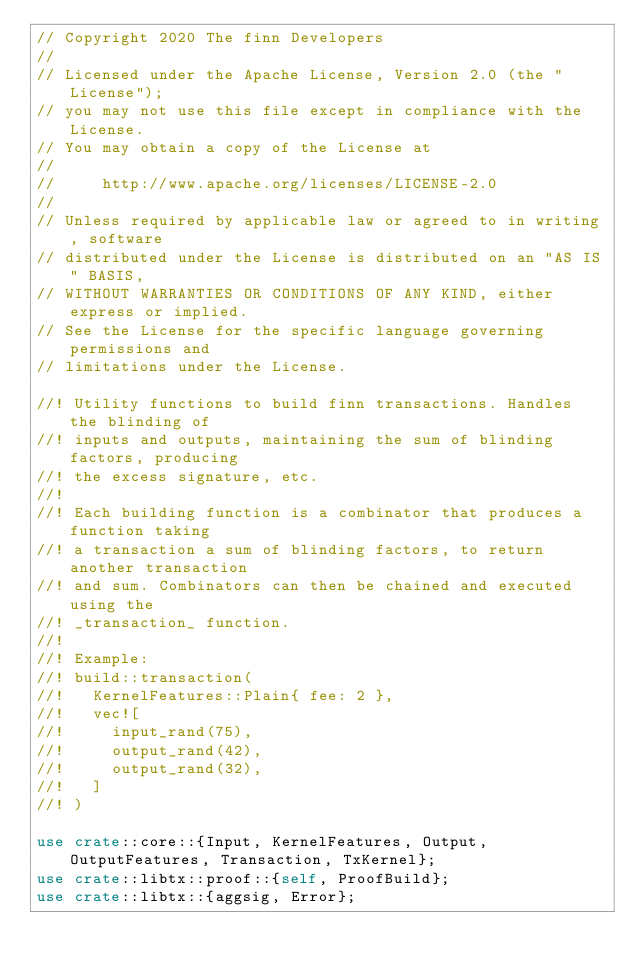<code> <loc_0><loc_0><loc_500><loc_500><_Rust_>// Copyright 2020 The finn Developers
//
// Licensed under the Apache License, Version 2.0 (the "License");
// you may not use this file except in compliance with the License.
// You may obtain a copy of the License at
//
//     http://www.apache.org/licenses/LICENSE-2.0
//
// Unless required by applicable law or agreed to in writing, software
// distributed under the License is distributed on an "AS IS" BASIS,
// WITHOUT WARRANTIES OR CONDITIONS OF ANY KIND, either express or implied.
// See the License for the specific language governing permissions and
// limitations under the License.

//! Utility functions to build finn transactions. Handles the blinding of
//! inputs and outputs, maintaining the sum of blinding factors, producing
//! the excess signature, etc.
//!
//! Each building function is a combinator that produces a function taking
//! a transaction a sum of blinding factors, to return another transaction
//! and sum. Combinators can then be chained and executed using the
//! _transaction_ function.
//!
//! Example:
//! build::transaction(
//!   KernelFeatures::Plain{ fee: 2 },
//!   vec![
//!     input_rand(75),
//!     output_rand(42),
//!     output_rand(32),
//!   ]
//! )

use crate::core::{Input, KernelFeatures, Output, OutputFeatures, Transaction, TxKernel};
use crate::libtx::proof::{self, ProofBuild};
use crate::libtx::{aggsig, Error};</code> 